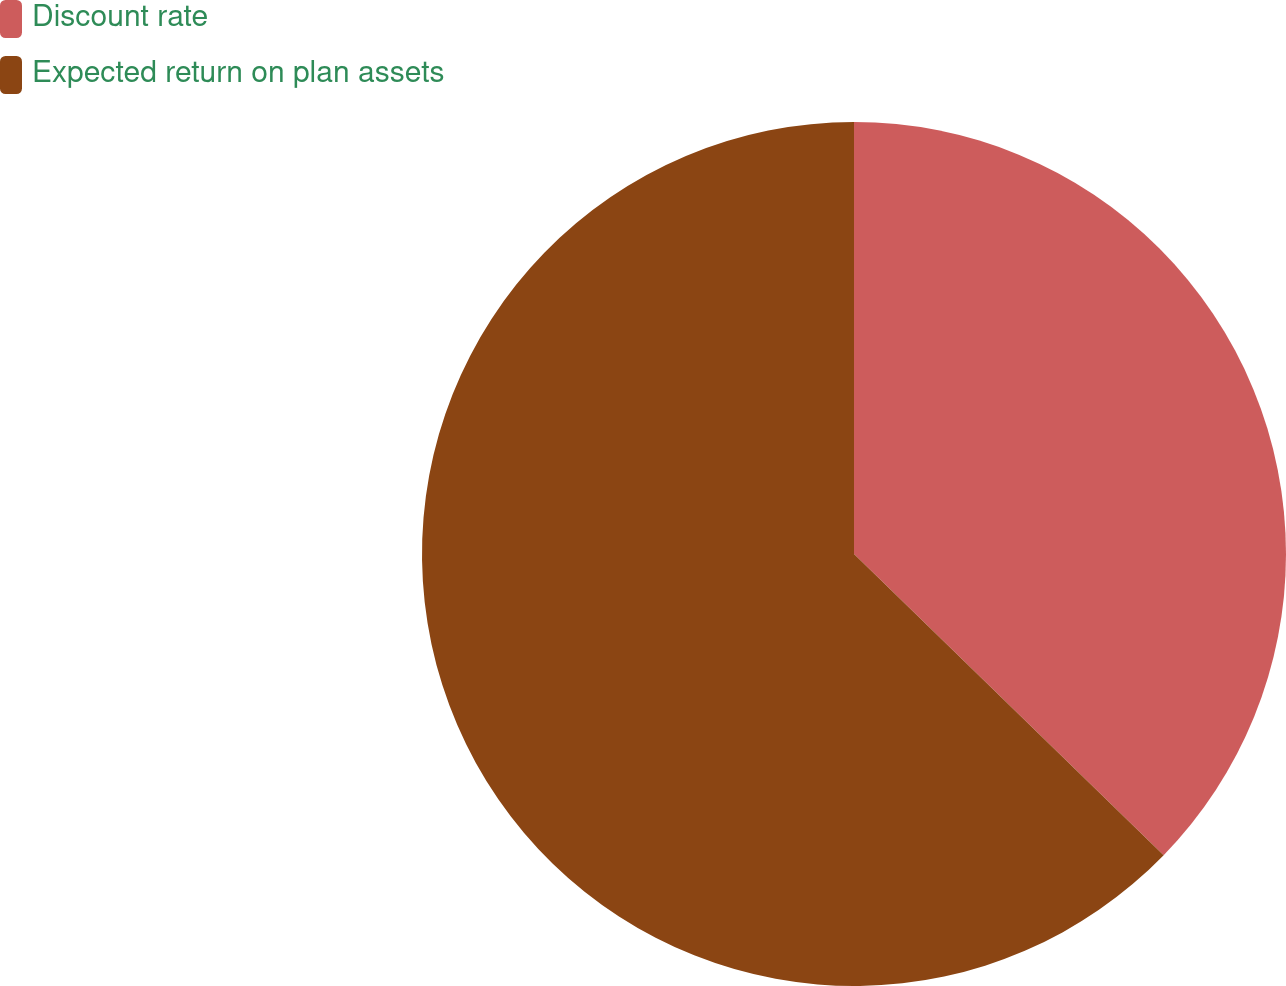Convert chart. <chart><loc_0><loc_0><loc_500><loc_500><pie_chart><fcel>Discount rate<fcel>Expected return on plan assets<nl><fcel>37.28%<fcel>62.72%<nl></chart> 